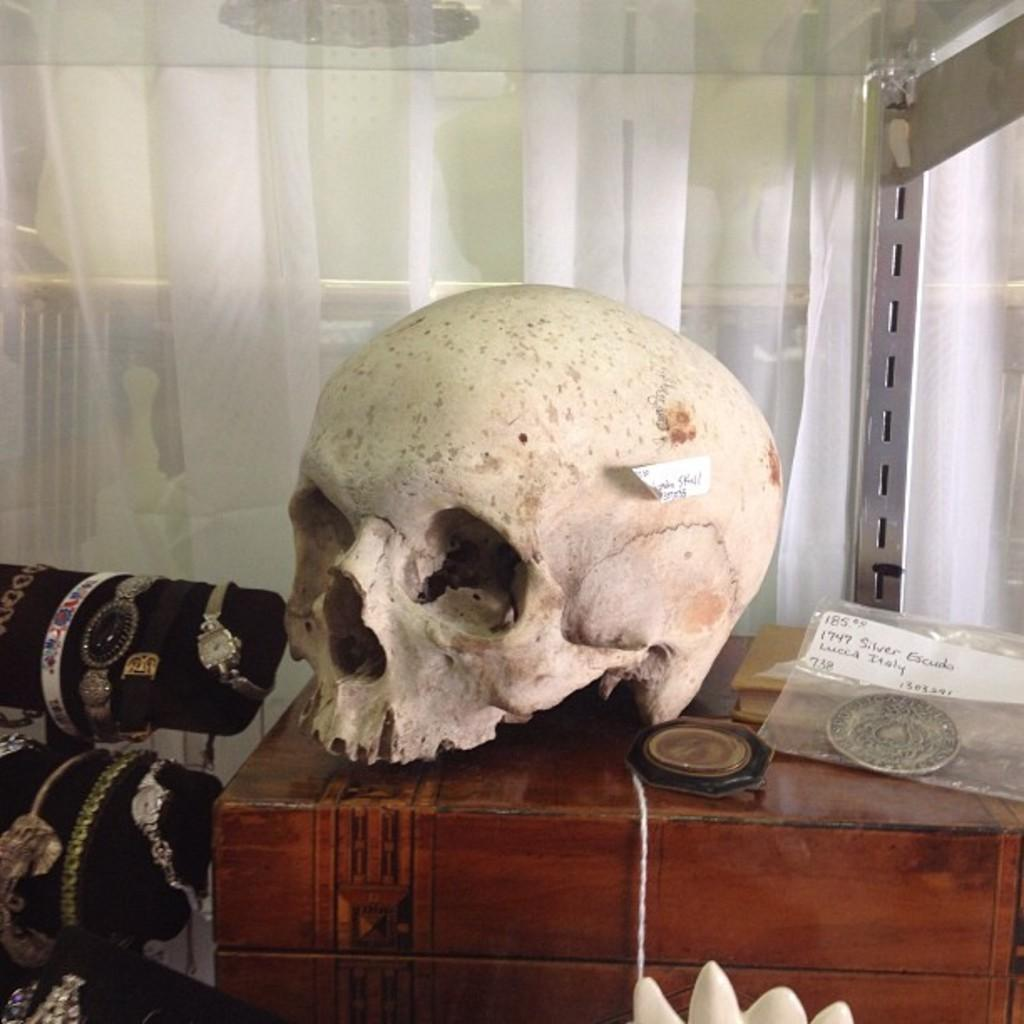What object is the main focus of the image? There is a wooden box in the image. What is on top of the wooden box? There is a skull and a book on the wooden box. What other items are on the wooden box? There are unspecified "things" on the wooden box. What can be seen in the background of the image? There is a white curtain in the image. What types of accessories are present in the image? There are wrist watches and bracelets in the image. What type of spring is visible in the image? There is no spring present in the image. What mark can be seen on the skull in the image? The provided facts do not mention any mark on the skull, so we cannot determine if there is a mark on it. 